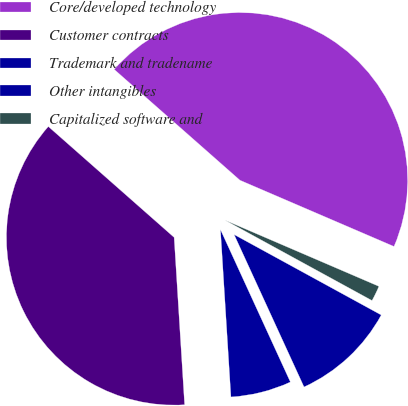Convert chart to OTSL. <chart><loc_0><loc_0><loc_500><loc_500><pie_chart><fcel>Core/developed technology<fcel>Customer contracts<fcel>Trademark and tradename<fcel>Other intangibles<fcel>Capitalized software and<nl><fcel>44.96%<fcel>37.49%<fcel>5.85%<fcel>10.19%<fcel>1.5%<nl></chart> 